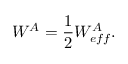Convert formula to latex. <formula><loc_0><loc_0><loc_500><loc_500>W ^ { A } = \frac { 1 } { 2 } W _ { e f f } ^ { A } .</formula> 